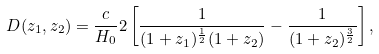<formula> <loc_0><loc_0><loc_500><loc_500>D ( z _ { 1 } , z _ { 2 } ) = \frac { c } { H _ { 0 } } 2 \left [ \frac { 1 } { ( 1 + z _ { 1 } ) ^ { \frac { 1 } { 2 } } ( 1 + z _ { 2 } ) } - \frac { 1 } { ( 1 + z _ { 2 } ) ^ { \frac { 3 } { 2 } } } \right ] ,</formula> 